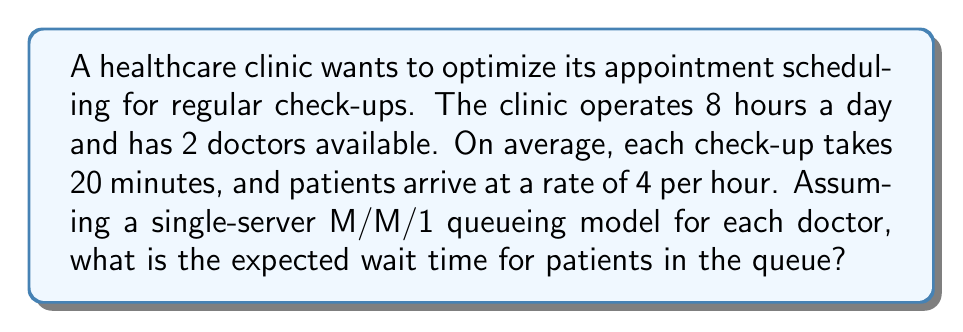Show me your answer to this math problem. To solve this problem, we'll use the M/M/1 queueing theory model. Here's the step-by-step approach:

1. Calculate the service rate (μ):
   Each doctor can serve $\frac{60 \text{ minutes}}{20 \text{ minutes/patient}} = 3$ patients per hour.
   $\mu = 3$ patients/hour/doctor

2. Calculate the arrival rate (λ) for each doctor:
   Total arrival rate is 4 patients/hour, split between 2 doctors.
   $\lambda = \frac{4}{2} = 2$ patients/hour/doctor

3. Calculate the utilization factor (ρ):
   $\rho = \frac{\lambda}{\mu} = \frac{2}{3} \approx 0.67$

4. Use the M/M/1 queue formula for expected wait time in the queue:
   $$W_q = \frac{\rho}{\mu - \lambda} = \frac{\rho}{\mu(1-\rho)}$$

5. Substitute the values:
   $$W_q = \frac{2/3}{3(1-2/3)} = \frac{2/3}{3(1/3)} = \frac{2/3}{1} = \frac{2}{3}$$

6. Convert the result to minutes:
   $\frac{2}{3}$ hour = $\frac{2}{3} \times 60$ minutes = 40 minutes

Therefore, the expected wait time for patients in the queue is 40 minutes.
Answer: 40 minutes 